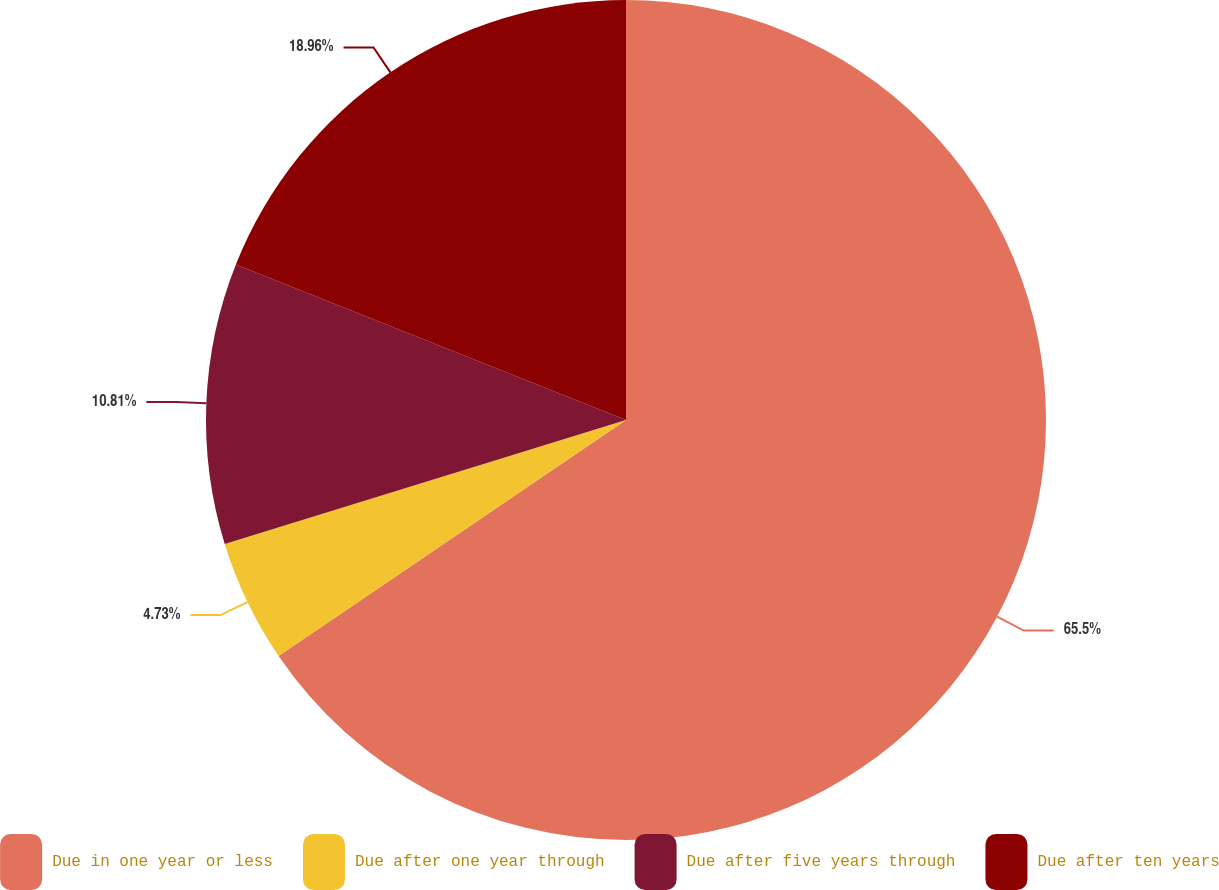Convert chart. <chart><loc_0><loc_0><loc_500><loc_500><pie_chart><fcel>Due in one year or less<fcel>Due after one year through<fcel>Due after five years through<fcel>Due after ten years<nl><fcel>65.5%<fcel>4.73%<fcel>10.81%<fcel>18.96%<nl></chart> 